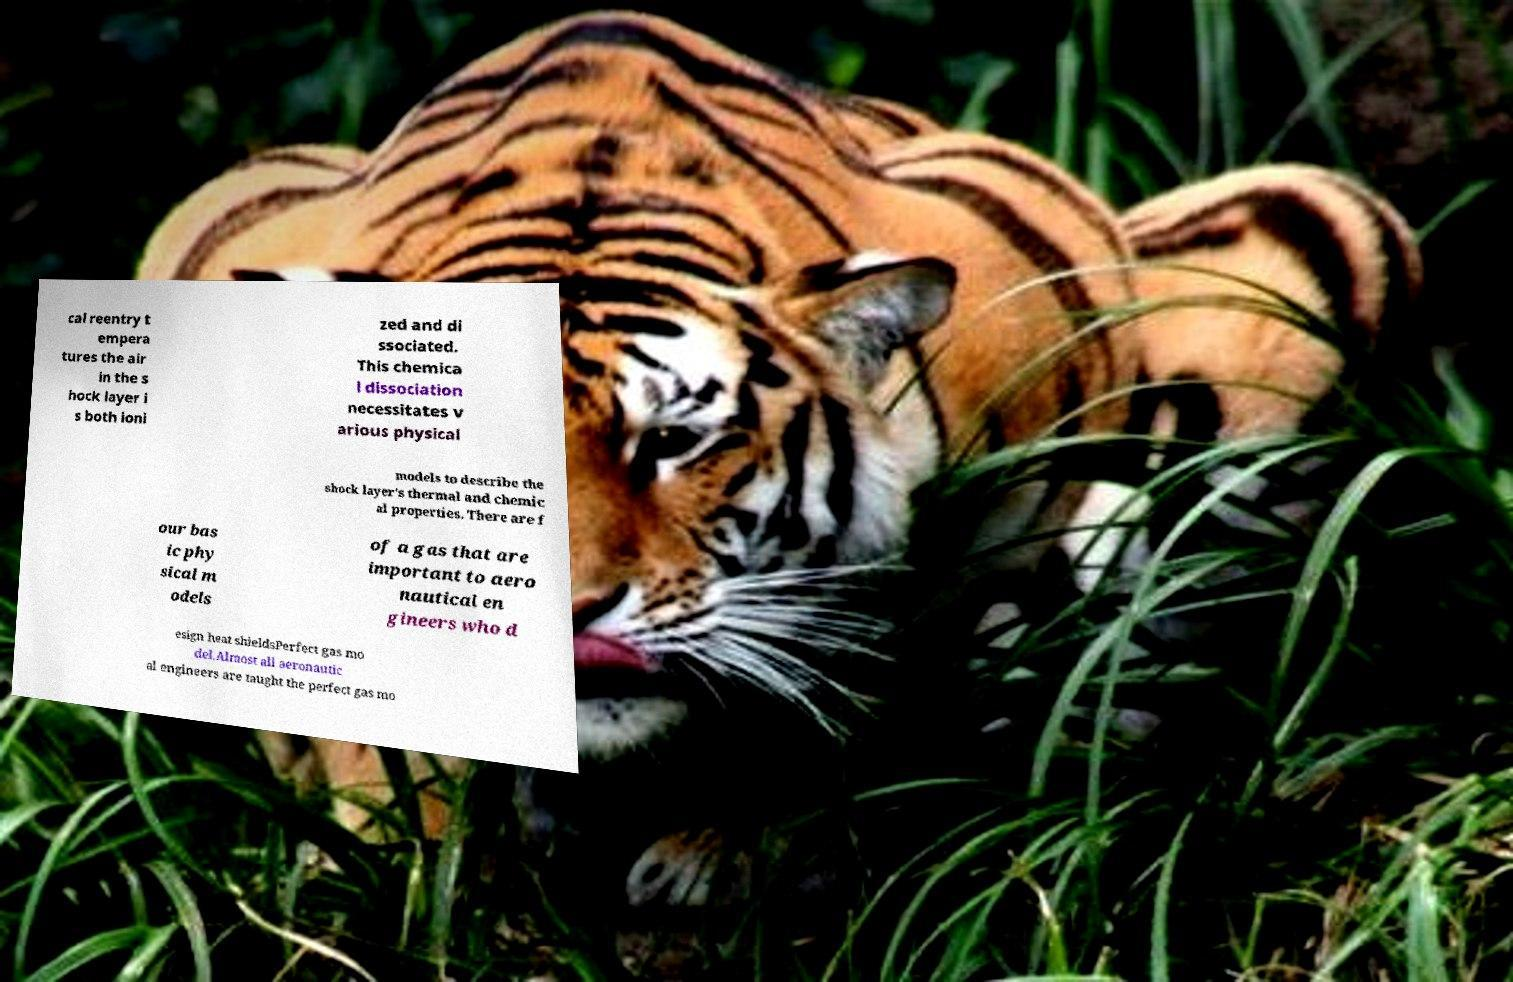For documentation purposes, I need the text within this image transcribed. Could you provide that? cal reentry t empera tures the air in the s hock layer i s both ioni zed and di ssociated. This chemica l dissociation necessitates v arious physical models to describe the shock layer's thermal and chemic al properties. There are f our bas ic phy sical m odels of a gas that are important to aero nautical en gineers who d esign heat shieldsPerfect gas mo del.Almost all aeronautic al engineers are taught the perfect gas mo 